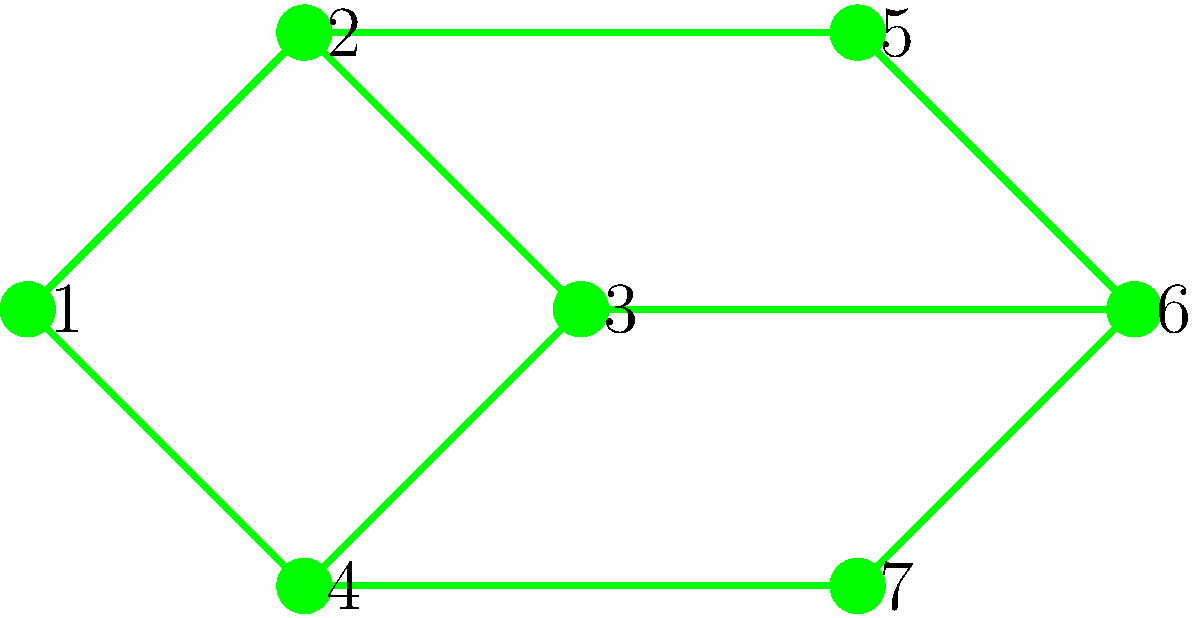As an eco-friendly city architect, you're designing an interconnected park system. The graph represents green spaces (vertices) and potential walking paths (edges). What is the minimum number of paths needed to connect all green spaces while ensuring that removing any single path won't disconnect the system? To solve this problem, we need to find the minimum spanning tree of the graph while ensuring redundancy. This concept is known as a minimum 2-edge-connected spanning subgraph. Here's the step-by-step approach:

1. Identify the total number of vertices (green spaces): 7

2. For a minimum spanning tree, we would need 6 edges (n-1, where n is the number of vertices).

3. However, to ensure that removing any single path won't disconnect the system, we need to add redundancy.

4. The minimum number of additional edges required for 2-edge-connectivity is 1.

5. Therefore, the total number of paths needed is:
   Minimum spanning tree edges + Additional edge for 2-edge-connectivity
   = (7-1) + 1 = 6 + 1 = 7

This solution creates a system where:
- All green spaces are connected
- Removing any single path won't disconnect the system
- The number of paths is minimized while maintaining connectivity and redundancy
Answer: 7 paths 